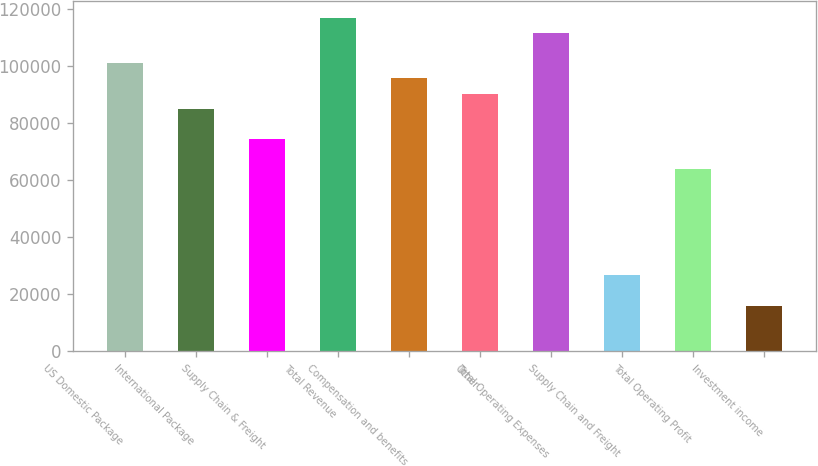Convert chart. <chart><loc_0><loc_0><loc_500><loc_500><bar_chart><fcel>US Domestic Package<fcel>International Package<fcel>Supply Chain & Freight<fcel>Total Revenue<fcel>Compensation and benefits<fcel>Other<fcel>Total Operating Expenses<fcel>Supply Chain and Freight<fcel>Total Operating Profit<fcel>Investment income<nl><fcel>100898<fcel>84966.7<fcel>74346.1<fcel>116828<fcel>95587.3<fcel>90277<fcel>111518<fcel>26553.5<fcel>63725.6<fcel>15933<nl></chart> 